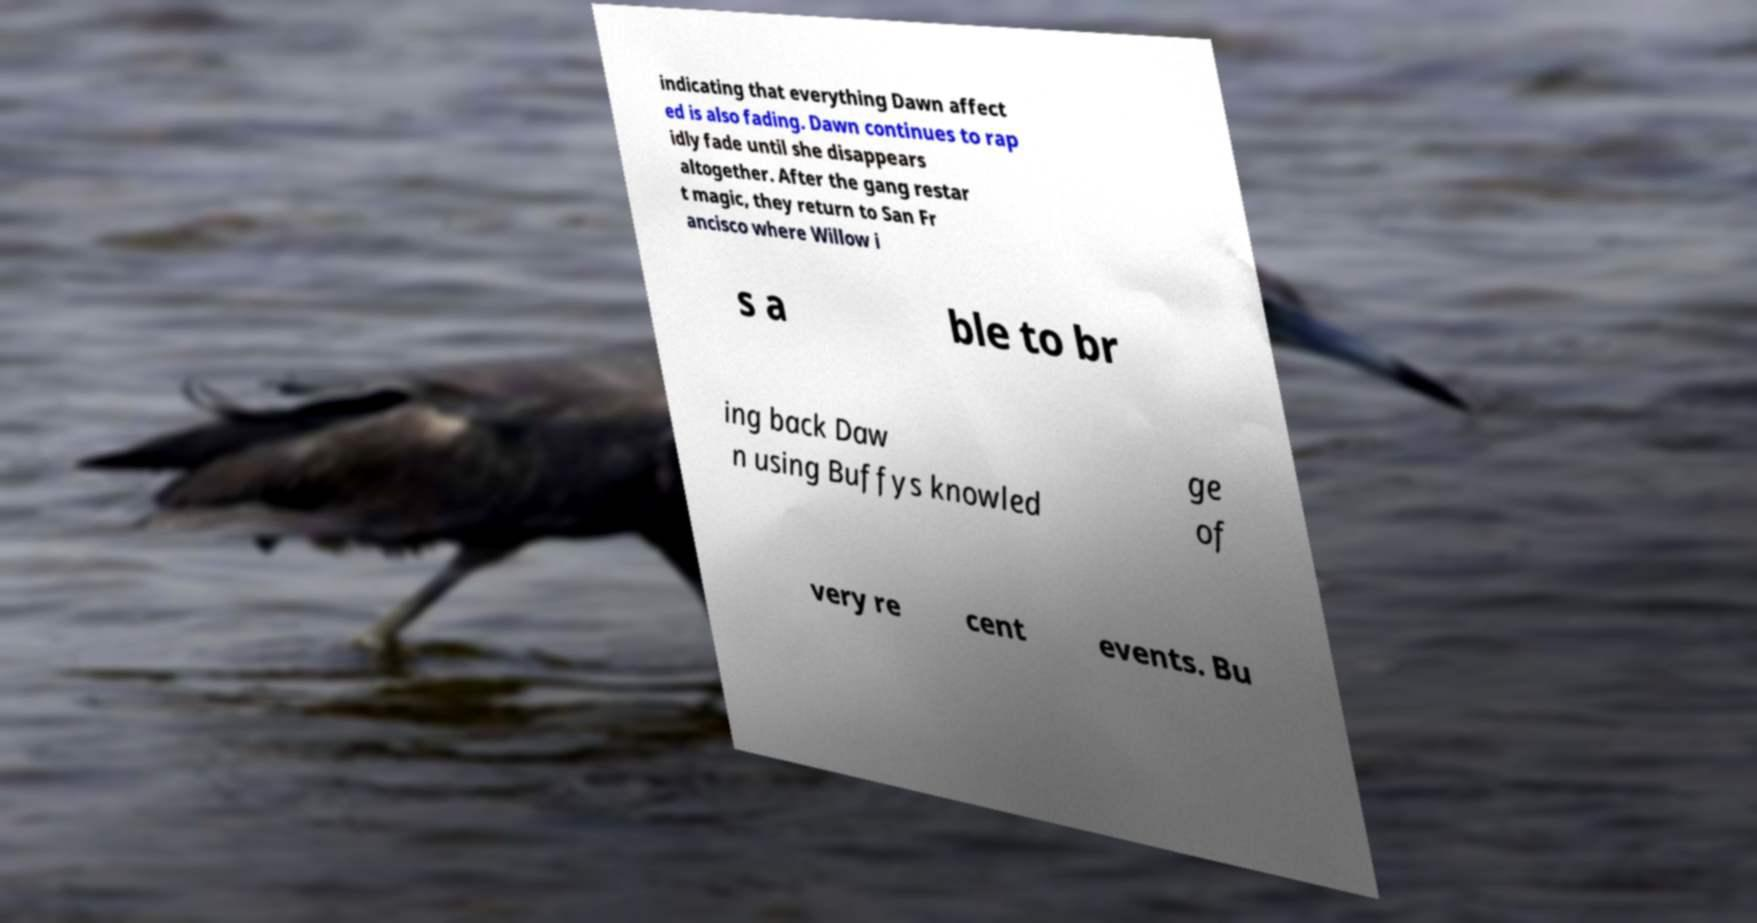I need the written content from this picture converted into text. Can you do that? indicating that everything Dawn affect ed is also fading. Dawn continues to rap idly fade until she disappears altogether. After the gang restar t magic, they return to San Fr ancisco where Willow i s a ble to br ing back Daw n using Buffys knowled ge of very re cent events. Bu 